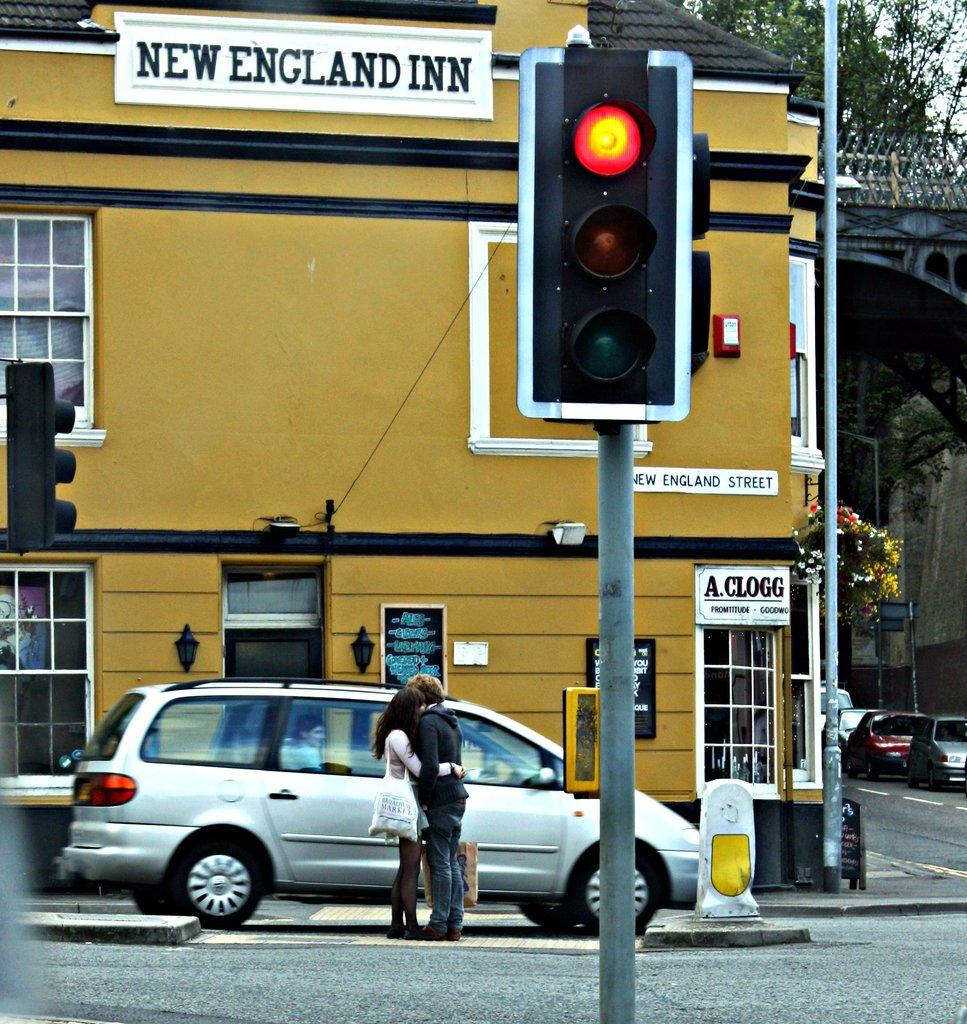<image>
Give a short and clear explanation of the subsequent image. A couple is embracing in an intersection that is in front of the New England Inn. 